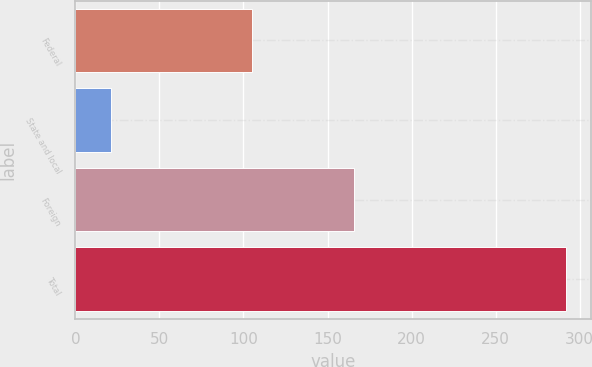Convert chart. <chart><loc_0><loc_0><loc_500><loc_500><bar_chart><fcel>Federal<fcel>State and local<fcel>Foreign<fcel>Total<nl><fcel>105<fcel>21<fcel>166<fcel>292<nl></chart> 